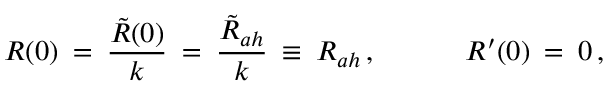<formula> <loc_0><loc_0><loc_500><loc_500>R ( 0 ) \, = \, \frac { \tilde { R } ( 0 ) } { k } \, = \, \frac { \tilde { R } _ { a h } } { k } \, \equiv \, R _ { a h } \, , \, R ^ { \prime } ( 0 ) \, = \, 0 \, ,</formula> 